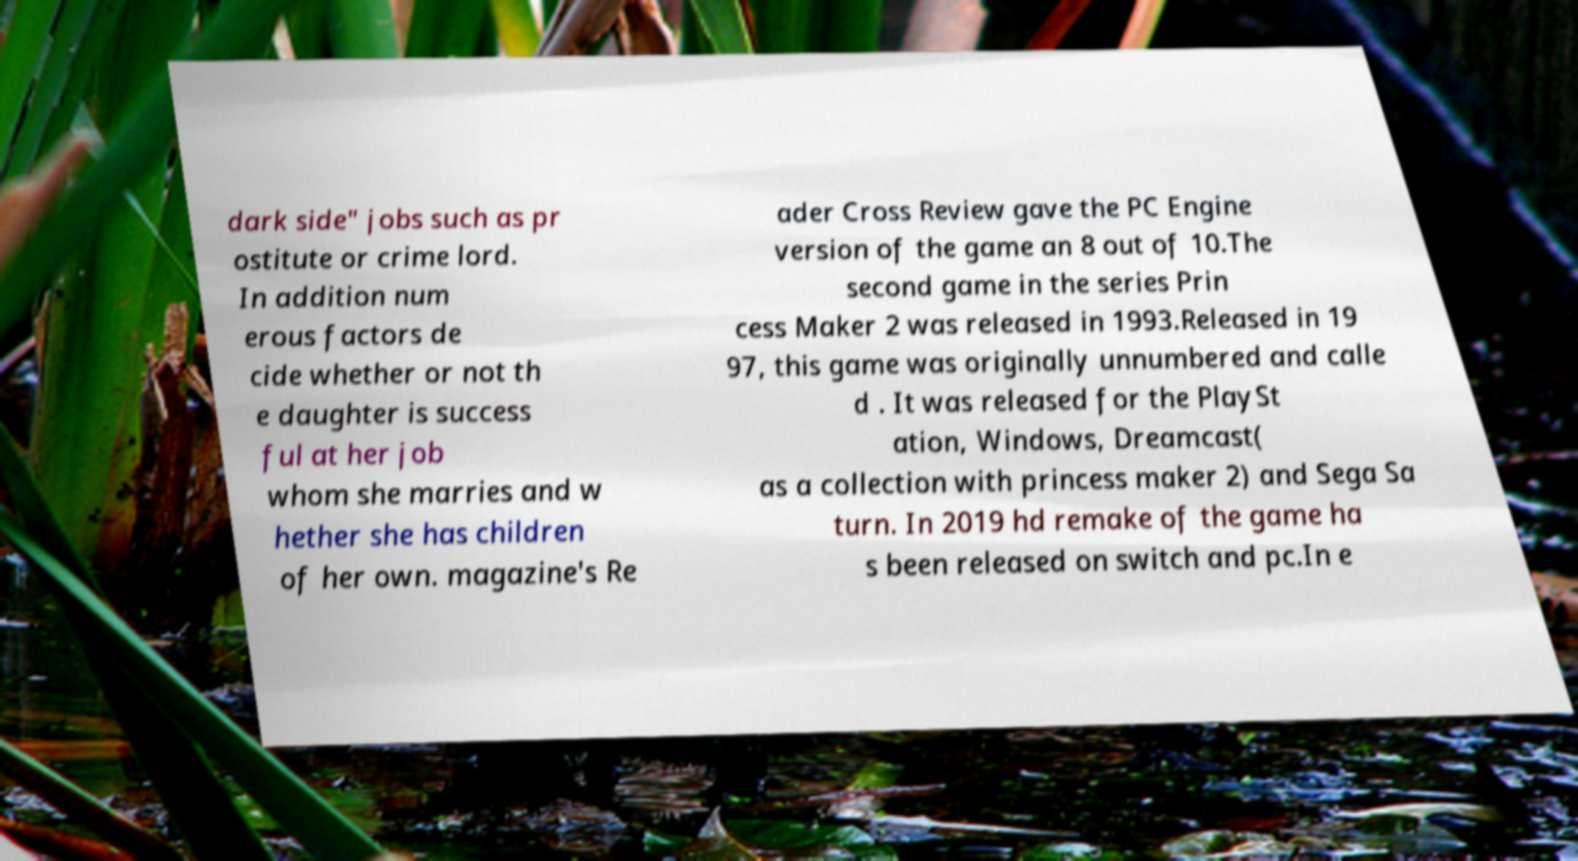I need the written content from this picture converted into text. Can you do that? dark side" jobs such as pr ostitute or crime lord. In addition num erous factors de cide whether or not th e daughter is success ful at her job whom she marries and w hether she has children of her own. magazine's Re ader Cross Review gave the PC Engine version of the game an 8 out of 10.The second game in the series Prin cess Maker 2 was released in 1993.Released in 19 97, this game was originally unnumbered and calle d . It was released for the PlaySt ation, Windows, Dreamcast( as a collection with princess maker 2) and Sega Sa turn. In 2019 hd remake of the game ha s been released on switch and pc.In e 